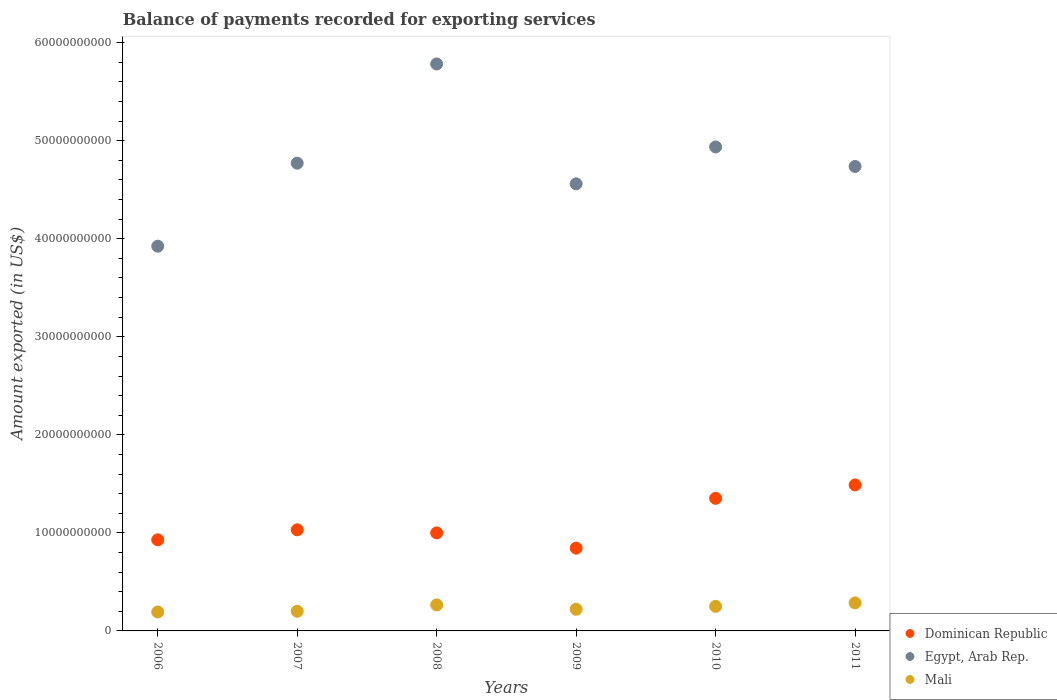What is the amount exported in Egypt, Arab Rep. in 2007?
Your answer should be very brief. 4.77e+1. Across all years, what is the maximum amount exported in Dominican Republic?
Make the answer very short. 1.49e+1. Across all years, what is the minimum amount exported in Dominican Republic?
Offer a very short reply. 8.44e+09. In which year was the amount exported in Egypt, Arab Rep. minimum?
Ensure brevity in your answer.  2006. What is the total amount exported in Mali in the graph?
Offer a terse response. 1.42e+1. What is the difference between the amount exported in Egypt, Arab Rep. in 2007 and that in 2011?
Give a very brief answer. 3.36e+08. What is the difference between the amount exported in Egypt, Arab Rep. in 2008 and the amount exported in Dominican Republic in 2007?
Your answer should be compact. 4.75e+1. What is the average amount exported in Dominican Republic per year?
Your answer should be very brief. 1.11e+1. In the year 2006, what is the difference between the amount exported in Dominican Republic and amount exported in Mali?
Provide a short and direct response. 7.36e+09. What is the ratio of the amount exported in Egypt, Arab Rep. in 2009 to that in 2011?
Provide a short and direct response. 0.96. Is the amount exported in Mali in 2006 less than that in 2011?
Your response must be concise. Yes. What is the difference between the highest and the second highest amount exported in Mali?
Offer a terse response. 2.06e+08. What is the difference between the highest and the lowest amount exported in Dominican Republic?
Ensure brevity in your answer.  6.45e+09. Is the sum of the amount exported in Mali in 2006 and 2009 greater than the maximum amount exported in Dominican Republic across all years?
Your response must be concise. No. Does the graph contain any zero values?
Keep it short and to the point. No. Does the graph contain grids?
Provide a succinct answer. No. Where does the legend appear in the graph?
Ensure brevity in your answer.  Bottom right. How many legend labels are there?
Your response must be concise. 3. What is the title of the graph?
Provide a succinct answer. Balance of payments recorded for exporting services. What is the label or title of the Y-axis?
Provide a succinct answer. Amount exported (in US$). What is the Amount exported (in US$) of Dominican Republic in 2006?
Make the answer very short. 9.29e+09. What is the Amount exported (in US$) in Egypt, Arab Rep. in 2006?
Provide a short and direct response. 3.92e+1. What is the Amount exported (in US$) in Mali in 2006?
Your answer should be compact. 1.93e+09. What is the Amount exported (in US$) in Dominican Republic in 2007?
Ensure brevity in your answer.  1.03e+1. What is the Amount exported (in US$) of Egypt, Arab Rep. in 2007?
Your response must be concise. 4.77e+1. What is the Amount exported (in US$) of Mali in 2007?
Provide a succinct answer. 2.00e+09. What is the Amount exported (in US$) of Dominican Republic in 2008?
Offer a terse response. 1.00e+1. What is the Amount exported (in US$) in Egypt, Arab Rep. in 2008?
Ensure brevity in your answer.  5.78e+1. What is the Amount exported (in US$) of Mali in 2008?
Your answer should be compact. 2.65e+09. What is the Amount exported (in US$) in Dominican Republic in 2009?
Provide a short and direct response. 8.44e+09. What is the Amount exported (in US$) of Egypt, Arab Rep. in 2009?
Offer a very short reply. 4.56e+1. What is the Amount exported (in US$) of Mali in 2009?
Give a very brief answer. 2.21e+09. What is the Amount exported (in US$) in Dominican Republic in 2010?
Offer a terse response. 1.35e+1. What is the Amount exported (in US$) in Egypt, Arab Rep. in 2010?
Make the answer very short. 4.94e+1. What is the Amount exported (in US$) in Mali in 2010?
Keep it short and to the point. 2.51e+09. What is the Amount exported (in US$) of Dominican Republic in 2011?
Provide a succinct answer. 1.49e+1. What is the Amount exported (in US$) in Egypt, Arab Rep. in 2011?
Offer a terse response. 4.74e+1. What is the Amount exported (in US$) of Mali in 2011?
Your answer should be compact. 2.86e+09. Across all years, what is the maximum Amount exported (in US$) in Dominican Republic?
Give a very brief answer. 1.49e+1. Across all years, what is the maximum Amount exported (in US$) in Egypt, Arab Rep.?
Offer a terse response. 5.78e+1. Across all years, what is the maximum Amount exported (in US$) in Mali?
Your response must be concise. 2.86e+09. Across all years, what is the minimum Amount exported (in US$) in Dominican Republic?
Keep it short and to the point. 8.44e+09. Across all years, what is the minimum Amount exported (in US$) in Egypt, Arab Rep.?
Offer a very short reply. 3.92e+1. Across all years, what is the minimum Amount exported (in US$) of Mali?
Provide a succinct answer. 1.93e+09. What is the total Amount exported (in US$) of Dominican Republic in the graph?
Provide a short and direct response. 6.65e+1. What is the total Amount exported (in US$) of Egypt, Arab Rep. in the graph?
Your answer should be compact. 2.87e+11. What is the total Amount exported (in US$) in Mali in the graph?
Provide a short and direct response. 1.42e+1. What is the difference between the Amount exported (in US$) in Dominican Republic in 2006 and that in 2007?
Provide a short and direct response. -1.02e+09. What is the difference between the Amount exported (in US$) of Egypt, Arab Rep. in 2006 and that in 2007?
Your answer should be compact. -8.47e+09. What is the difference between the Amount exported (in US$) in Mali in 2006 and that in 2007?
Give a very brief answer. -7.17e+07. What is the difference between the Amount exported (in US$) in Dominican Republic in 2006 and that in 2008?
Provide a short and direct response. -7.08e+08. What is the difference between the Amount exported (in US$) of Egypt, Arab Rep. in 2006 and that in 2008?
Make the answer very short. -1.86e+1. What is the difference between the Amount exported (in US$) in Mali in 2006 and that in 2008?
Your answer should be compact. -7.21e+08. What is the difference between the Amount exported (in US$) of Dominican Republic in 2006 and that in 2009?
Your response must be concise. 8.48e+08. What is the difference between the Amount exported (in US$) of Egypt, Arab Rep. in 2006 and that in 2009?
Your response must be concise. -6.36e+09. What is the difference between the Amount exported (in US$) in Mali in 2006 and that in 2009?
Provide a short and direct response. -2.77e+08. What is the difference between the Amount exported (in US$) of Dominican Republic in 2006 and that in 2010?
Offer a very short reply. -4.23e+09. What is the difference between the Amount exported (in US$) of Egypt, Arab Rep. in 2006 and that in 2010?
Provide a short and direct response. -1.01e+1. What is the difference between the Amount exported (in US$) of Mali in 2006 and that in 2010?
Provide a short and direct response. -5.76e+08. What is the difference between the Amount exported (in US$) in Dominican Republic in 2006 and that in 2011?
Your answer should be very brief. -5.60e+09. What is the difference between the Amount exported (in US$) in Egypt, Arab Rep. in 2006 and that in 2011?
Your answer should be very brief. -8.13e+09. What is the difference between the Amount exported (in US$) in Mali in 2006 and that in 2011?
Your answer should be compact. -9.26e+08. What is the difference between the Amount exported (in US$) in Dominican Republic in 2007 and that in 2008?
Give a very brief answer. 3.16e+08. What is the difference between the Amount exported (in US$) of Egypt, Arab Rep. in 2007 and that in 2008?
Your answer should be compact. -1.01e+1. What is the difference between the Amount exported (in US$) in Mali in 2007 and that in 2008?
Ensure brevity in your answer.  -6.49e+08. What is the difference between the Amount exported (in US$) of Dominican Republic in 2007 and that in 2009?
Provide a succinct answer. 1.87e+09. What is the difference between the Amount exported (in US$) of Egypt, Arab Rep. in 2007 and that in 2009?
Give a very brief answer. 2.11e+09. What is the difference between the Amount exported (in US$) of Mali in 2007 and that in 2009?
Provide a short and direct response. -2.05e+08. What is the difference between the Amount exported (in US$) in Dominican Republic in 2007 and that in 2010?
Offer a very short reply. -3.21e+09. What is the difference between the Amount exported (in US$) in Egypt, Arab Rep. in 2007 and that in 2010?
Offer a very short reply. -1.66e+09. What is the difference between the Amount exported (in US$) in Mali in 2007 and that in 2010?
Ensure brevity in your answer.  -5.04e+08. What is the difference between the Amount exported (in US$) of Dominican Republic in 2007 and that in 2011?
Ensure brevity in your answer.  -4.58e+09. What is the difference between the Amount exported (in US$) in Egypt, Arab Rep. in 2007 and that in 2011?
Ensure brevity in your answer.  3.36e+08. What is the difference between the Amount exported (in US$) of Mali in 2007 and that in 2011?
Keep it short and to the point. -8.55e+08. What is the difference between the Amount exported (in US$) in Dominican Republic in 2008 and that in 2009?
Ensure brevity in your answer.  1.56e+09. What is the difference between the Amount exported (in US$) in Egypt, Arab Rep. in 2008 and that in 2009?
Provide a succinct answer. 1.22e+1. What is the difference between the Amount exported (in US$) in Mali in 2008 and that in 2009?
Offer a terse response. 4.43e+08. What is the difference between the Amount exported (in US$) of Dominican Republic in 2008 and that in 2010?
Your response must be concise. -3.53e+09. What is the difference between the Amount exported (in US$) in Egypt, Arab Rep. in 2008 and that in 2010?
Make the answer very short. 8.46e+09. What is the difference between the Amount exported (in US$) of Mali in 2008 and that in 2010?
Ensure brevity in your answer.  1.45e+08. What is the difference between the Amount exported (in US$) of Dominican Republic in 2008 and that in 2011?
Give a very brief answer. -4.89e+09. What is the difference between the Amount exported (in US$) in Egypt, Arab Rep. in 2008 and that in 2011?
Offer a very short reply. 1.05e+1. What is the difference between the Amount exported (in US$) in Mali in 2008 and that in 2011?
Give a very brief answer. -2.06e+08. What is the difference between the Amount exported (in US$) of Dominican Republic in 2009 and that in 2010?
Ensure brevity in your answer.  -5.08e+09. What is the difference between the Amount exported (in US$) in Egypt, Arab Rep. in 2009 and that in 2010?
Give a very brief answer. -3.76e+09. What is the difference between the Amount exported (in US$) of Mali in 2009 and that in 2010?
Give a very brief answer. -2.98e+08. What is the difference between the Amount exported (in US$) in Dominican Republic in 2009 and that in 2011?
Your response must be concise. -6.45e+09. What is the difference between the Amount exported (in US$) of Egypt, Arab Rep. in 2009 and that in 2011?
Offer a very short reply. -1.77e+09. What is the difference between the Amount exported (in US$) of Mali in 2009 and that in 2011?
Provide a short and direct response. -6.49e+08. What is the difference between the Amount exported (in US$) of Dominican Republic in 2010 and that in 2011?
Keep it short and to the point. -1.36e+09. What is the difference between the Amount exported (in US$) in Egypt, Arab Rep. in 2010 and that in 2011?
Provide a succinct answer. 1.99e+09. What is the difference between the Amount exported (in US$) of Mali in 2010 and that in 2011?
Offer a terse response. -3.51e+08. What is the difference between the Amount exported (in US$) of Dominican Republic in 2006 and the Amount exported (in US$) of Egypt, Arab Rep. in 2007?
Your answer should be compact. -3.84e+1. What is the difference between the Amount exported (in US$) in Dominican Republic in 2006 and the Amount exported (in US$) in Mali in 2007?
Keep it short and to the point. 7.29e+09. What is the difference between the Amount exported (in US$) of Egypt, Arab Rep. in 2006 and the Amount exported (in US$) of Mali in 2007?
Ensure brevity in your answer.  3.72e+1. What is the difference between the Amount exported (in US$) in Dominican Republic in 2006 and the Amount exported (in US$) in Egypt, Arab Rep. in 2008?
Give a very brief answer. -4.85e+1. What is the difference between the Amount exported (in US$) of Dominican Republic in 2006 and the Amount exported (in US$) of Mali in 2008?
Give a very brief answer. 6.64e+09. What is the difference between the Amount exported (in US$) of Egypt, Arab Rep. in 2006 and the Amount exported (in US$) of Mali in 2008?
Make the answer very short. 3.66e+1. What is the difference between the Amount exported (in US$) in Dominican Republic in 2006 and the Amount exported (in US$) in Egypt, Arab Rep. in 2009?
Ensure brevity in your answer.  -3.63e+1. What is the difference between the Amount exported (in US$) in Dominican Republic in 2006 and the Amount exported (in US$) in Mali in 2009?
Offer a very short reply. 7.08e+09. What is the difference between the Amount exported (in US$) of Egypt, Arab Rep. in 2006 and the Amount exported (in US$) of Mali in 2009?
Ensure brevity in your answer.  3.70e+1. What is the difference between the Amount exported (in US$) in Dominican Republic in 2006 and the Amount exported (in US$) in Egypt, Arab Rep. in 2010?
Your answer should be compact. -4.01e+1. What is the difference between the Amount exported (in US$) in Dominican Republic in 2006 and the Amount exported (in US$) in Mali in 2010?
Offer a very short reply. 6.78e+09. What is the difference between the Amount exported (in US$) in Egypt, Arab Rep. in 2006 and the Amount exported (in US$) in Mali in 2010?
Your response must be concise. 3.67e+1. What is the difference between the Amount exported (in US$) of Dominican Republic in 2006 and the Amount exported (in US$) of Egypt, Arab Rep. in 2011?
Offer a terse response. -3.81e+1. What is the difference between the Amount exported (in US$) in Dominican Republic in 2006 and the Amount exported (in US$) in Mali in 2011?
Make the answer very short. 6.43e+09. What is the difference between the Amount exported (in US$) of Egypt, Arab Rep. in 2006 and the Amount exported (in US$) of Mali in 2011?
Offer a very short reply. 3.64e+1. What is the difference between the Amount exported (in US$) of Dominican Republic in 2007 and the Amount exported (in US$) of Egypt, Arab Rep. in 2008?
Ensure brevity in your answer.  -4.75e+1. What is the difference between the Amount exported (in US$) of Dominican Republic in 2007 and the Amount exported (in US$) of Mali in 2008?
Your response must be concise. 7.66e+09. What is the difference between the Amount exported (in US$) of Egypt, Arab Rep. in 2007 and the Amount exported (in US$) of Mali in 2008?
Ensure brevity in your answer.  4.51e+1. What is the difference between the Amount exported (in US$) in Dominican Republic in 2007 and the Amount exported (in US$) in Egypt, Arab Rep. in 2009?
Provide a short and direct response. -3.53e+1. What is the difference between the Amount exported (in US$) of Dominican Republic in 2007 and the Amount exported (in US$) of Mali in 2009?
Provide a succinct answer. 8.10e+09. What is the difference between the Amount exported (in US$) of Egypt, Arab Rep. in 2007 and the Amount exported (in US$) of Mali in 2009?
Provide a succinct answer. 4.55e+1. What is the difference between the Amount exported (in US$) of Dominican Republic in 2007 and the Amount exported (in US$) of Egypt, Arab Rep. in 2010?
Provide a succinct answer. -3.91e+1. What is the difference between the Amount exported (in US$) of Dominican Republic in 2007 and the Amount exported (in US$) of Mali in 2010?
Make the answer very short. 7.81e+09. What is the difference between the Amount exported (in US$) of Egypt, Arab Rep. in 2007 and the Amount exported (in US$) of Mali in 2010?
Your answer should be compact. 4.52e+1. What is the difference between the Amount exported (in US$) in Dominican Republic in 2007 and the Amount exported (in US$) in Egypt, Arab Rep. in 2011?
Provide a succinct answer. -3.71e+1. What is the difference between the Amount exported (in US$) in Dominican Republic in 2007 and the Amount exported (in US$) in Mali in 2011?
Make the answer very short. 7.45e+09. What is the difference between the Amount exported (in US$) in Egypt, Arab Rep. in 2007 and the Amount exported (in US$) in Mali in 2011?
Make the answer very short. 4.48e+1. What is the difference between the Amount exported (in US$) of Dominican Republic in 2008 and the Amount exported (in US$) of Egypt, Arab Rep. in 2009?
Offer a very short reply. -3.56e+1. What is the difference between the Amount exported (in US$) in Dominican Republic in 2008 and the Amount exported (in US$) in Mali in 2009?
Provide a succinct answer. 7.79e+09. What is the difference between the Amount exported (in US$) in Egypt, Arab Rep. in 2008 and the Amount exported (in US$) in Mali in 2009?
Make the answer very short. 5.56e+1. What is the difference between the Amount exported (in US$) of Dominican Republic in 2008 and the Amount exported (in US$) of Egypt, Arab Rep. in 2010?
Your response must be concise. -3.94e+1. What is the difference between the Amount exported (in US$) of Dominican Republic in 2008 and the Amount exported (in US$) of Mali in 2010?
Your answer should be compact. 7.49e+09. What is the difference between the Amount exported (in US$) of Egypt, Arab Rep. in 2008 and the Amount exported (in US$) of Mali in 2010?
Offer a terse response. 5.53e+1. What is the difference between the Amount exported (in US$) of Dominican Republic in 2008 and the Amount exported (in US$) of Egypt, Arab Rep. in 2011?
Your answer should be compact. -3.74e+1. What is the difference between the Amount exported (in US$) of Dominican Republic in 2008 and the Amount exported (in US$) of Mali in 2011?
Your response must be concise. 7.14e+09. What is the difference between the Amount exported (in US$) of Egypt, Arab Rep. in 2008 and the Amount exported (in US$) of Mali in 2011?
Ensure brevity in your answer.  5.50e+1. What is the difference between the Amount exported (in US$) of Dominican Republic in 2009 and the Amount exported (in US$) of Egypt, Arab Rep. in 2010?
Provide a short and direct response. -4.09e+1. What is the difference between the Amount exported (in US$) in Dominican Republic in 2009 and the Amount exported (in US$) in Mali in 2010?
Ensure brevity in your answer.  5.94e+09. What is the difference between the Amount exported (in US$) in Egypt, Arab Rep. in 2009 and the Amount exported (in US$) in Mali in 2010?
Provide a short and direct response. 4.31e+1. What is the difference between the Amount exported (in US$) of Dominican Republic in 2009 and the Amount exported (in US$) of Egypt, Arab Rep. in 2011?
Offer a very short reply. -3.89e+1. What is the difference between the Amount exported (in US$) in Dominican Republic in 2009 and the Amount exported (in US$) in Mali in 2011?
Offer a terse response. 5.58e+09. What is the difference between the Amount exported (in US$) of Egypt, Arab Rep. in 2009 and the Amount exported (in US$) of Mali in 2011?
Provide a succinct answer. 4.27e+1. What is the difference between the Amount exported (in US$) of Dominican Republic in 2010 and the Amount exported (in US$) of Egypt, Arab Rep. in 2011?
Offer a terse response. -3.38e+1. What is the difference between the Amount exported (in US$) in Dominican Republic in 2010 and the Amount exported (in US$) in Mali in 2011?
Give a very brief answer. 1.07e+1. What is the difference between the Amount exported (in US$) in Egypt, Arab Rep. in 2010 and the Amount exported (in US$) in Mali in 2011?
Provide a short and direct response. 4.65e+1. What is the average Amount exported (in US$) of Dominican Republic per year?
Ensure brevity in your answer.  1.11e+1. What is the average Amount exported (in US$) of Egypt, Arab Rep. per year?
Offer a very short reply. 4.79e+1. What is the average Amount exported (in US$) in Mali per year?
Your response must be concise. 2.36e+09. In the year 2006, what is the difference between the Amount exported (in US$) in Dominican Republic and Amount exported (in US$) in Egypt, Arab Rep.?
Your answer should be compact. -2.99e+1. In the year 2006, what is the difference between the Amount exported (in US$) of Dominican Republic and Amount exported (in US$) of Mali?
Give a very brief answer. 7.36e+09. In the year 2006, what is the difference between the Amount exported (in US$) in Egypt, Arab Rep. and Amount exported (in US$) in Mali?
Provide a short and direct response. 3.73e+1. In the year 2007, what is the difference between the Amount exported (in US$) of Dominican Republic and Amount exported (in US$) of Egypt, Arab Rep.?
Ensure brevity in your answer.  -3.74e+1. In the year 2007, what is the difference between the Amount exported (in US$) in Dominican Republic and Amount exported (in US$) in Mali?
Provide a succinct answer. 8.31e+09. In the year 2007, what is the difference between the Amount exported (in US$) of Egypt, Arab Rep. and Amount exported (in US$) of Mali?
Keep it short and to the point. 4.57e+1. In the year 2008, what is the difference between the Amount exported (in US$) of Dominican Republic and Amount exported (in US$) of Egypt, Arab Rep.?
Give a very brief answer. -4.78e+1. In the year 2008, what is the difference between the Amount exported (in US$) in Dominican Republic and Amount exported (in US$) in Mali?
Your answer should be very brief. 7.35e+09. In the year 2008, what is the difference between the Amount exported (in US$) of Egypt, Arab Rep. and Amount exported (in US$) of Mali?
Provide a succinct answer. 5.52e+1. In the year 2009, what is the difference between the Amount exported (in US$) in Dominican Republic and Amount exported (in US$) in Egypt, Arab Rep.?
Make the answer very short. -3.72e+1. In the year 2009, what is the difference between the Amount exported (in US$) of Dominican Republic and Amount exported (in US$) of Mali?
Provide a short and direct response. 6.23e+09. In the year 2009, what is the difference between the Amount exported (in US$) in Egypt, Arab Rep. and Amount exported (in US$) in Mali?
Keep it short and to the point. 4.34e+1. In the year 2010, what is the difference between the Amount exported (in US$) of Dominican Republic and Amount exported (in US$) of Egypt, Arab Rep.?
Make the answer very short. -3.58e+1. In the year 2010, what is the difference between the Amount exported (in US$) of Dominican Republic and Amount exported (in US$) of Mali?
Offer a terse response. 1.10e+1. In the year 2010, what is the difference between the Amount exported (in US$) in Egypt, Arab Rep. and Amount exported (in US$) in Mali?
Make the answer very short. 4.69e+1. In the year 2011, what is the difference between the Amount exported (in US$) in Dominican Republic and Amount exported (in US$) in Egypt, Arab Rep.?
Provide a succinct answer. -3.25e+1. In the year 2011, what is the difference between the Amount exported (in US$) of Dominican Republic and Amount exported (in US$) of Mali?
Your answer should be very brief. 1.20e+1. In the year 2011, what is the difference between the Amount exported (in US$) in Egypt, Arab Rep. and Amount exported (in US$) in Mali?
Provide a succinct answer. 4.45e+1. What is the ratio of the Amount exported (in US$) in Dominican Republic in 2006 to that in 2007?
Your answer should be compact. 0.9. What is the ratio of the Amount exported (in US$) in Egypt, Arab Rep. in 2006 to that in 2007?
Ensure brevity in your answer.  0.82. What is the ratio of the Amount exported (in US$) in Mali in 2006 to that in 2007?
Provide a short and direct response. 0.96. What is the ratio of the Amount exported (in US$) of Dominican Republic in 2006 to that in 2008?
Offer a very short reply. 0.93. What is the ratio of the Amount exported (in US$) of Egypt, Arab Rep. in 2006 to that in 2008?
Make the answer very short. 0.68. What is the ratio of the Amount exported (in US$) of Mali in 2006 to that in 2008?
Give a very brief answer. 0.73. What is the ratio of the Amount exported (in US$) in Dominican Republic in 2006 to that in 2009?
Provide a short and direct response. 1.1. What is the ratio of the Amount exported (in US$) in Egypt, Arab Rep. in 2006 to that in 2009?
Ensure brevity in your answer.  0.86. What is the ratio of the Amount exported (in US$) in Mali in 2006 to that in 2009?
Offer a terse response. 0.87. What is the ratio of the Amount exported (in US$) in Dominican Republic in 2006 to that in 2010?
Give a very brief answer. 0.69. What is the ratio of the Amount exported (in US$) of Egypt, Arab Rep. in 2006 to that in 2010?
Ensure brevity in your answer.  0.79. What is the ratio of the Amount exported (in US$) of Mali in 2006 to that in 2010?
Make the answer very short. 0.77. What is the ratio of the Amount exported (in US$) of Dominican Republic in 2006 to that in 2011?
Provide a succinct answer. 0.62. What is the ratio of the Amount exported (in US$) in Egypt, Arab Rep. in 2006 to that in 2011?
Keep it short and to the point. 0.83. What is the ratio of the Amount exported (in US$) in Mali in 2006 to that in 2011?
Your answer should be compact. 0.68. What is the ratio of the Amount exported (in US$) in Dominican Republic in 2007 to that in 2008?
Make the answer very short. 1.03. What is the ratio of the Amount exported (in US$) in Egypt, Arab Rep. in 2007 to that in 2008?
Provide a short and direct response. 0.82. What is the ratio of the Amount exported (in US$) of Mali in 2007 to that in 2008?
Your response must be concise. 0.76. What is the ratio of the Amount exported (in US$) in Dominican Republic in 2007 to that in 2009?
Provide a short and direct response. 1.22. What is the ratio of the Amount exported (in US$) of Egypt, Arab Rep. in 2007 to that in 2009?
Ensure brevity in your answer.  1.05. What is the ratio of the Amount exported (in US$) in Mali in 2007 to that in 2009?
Ensure brevity in your answer.  0.91. What is the ratio of the Amount exported (in US$) of Dominican Republic in 2007 to that in 2010?
Offer a very short reply. 0.76. What is the ratio of the Amount exported (in US$) of Egypt, Arab Rep. in 2007 to that in 2010?
Provide a short and direct response. 0.97. What is the ratio of the Amount exported (in US$) of Mali in 2007 to that in 2010?
Ensure brevity in your answer.  0.8. What is the ratio of the Amount exported (in US$) in Dominican Republic in 2007 to that in 2011?
Ensure brevity in your answer.  0.69. What is the ratio of the Amount exported (in US$) in Egypt, Arab Rep. in 2007 to that in 2011?
Offer a terse response. 1.01. What is the ratio of the Amount exported (in US$) of Mali in 2007 to that in 2011?
Ensure brevity in your answer.  0.7. What is the ratio of the Amount exported (in US$) in Dominican Republic in 2008 to that in 2009?
Give a very brief answer. 1.18. What is the ratio of the Amount exported (in US$) in Egypt, Arab Rep. in 2008 to that in 2009?
Your answer should be very brief. 1.27. What is the ratio of the Amount exported (in US$) in Mali in 2008 to that in 2009?
Give a very brief answer. 1.2. What is the ratio of the Amount exported (in US$) of Dominican Republic in 2008 to that in 2010?
Make the answer very short. 0.74. What is the ratio of the Amount exported (in US$) of Egypt, Arab Rep. in 2008 to that in 2010?
Keep it short and to the point. 1.17. What is the ratio of the Amount exported (in US$) of Mali in 2008 to that in 2010?
Your response must be concise. 1.06. What is the ratio of the Amount exported (in US$) of Dominican Republic in 2008 to that in 2011?
Keep it short and to the point. 0.67. What is the ratio of the Amount exported (in US$) of Egypt, Arab Rep. in 2008 to that in 2011?
Provide a short and direct response. 1.22. What is the ratio of the Amount exported (in US$) in Mali in 2008 to that in 2011?
Your answer should be very brief. 0.93. What is the ratio of the Amount exported (in US$) of Dominican Republic in 2009 to that in 2010?
Offer a terse response. 0.62. What is the ratio of the Amount exported (in US$) in Egypt, Arab Rep. in 2009 to that in 2010?
Your response must be concise. 0.92. What is the ratio of the Amount exported (in US$) of Mali in 2009 to that in 2010?
Keep it short and to the point. 0.88. What is the ratio of the Amount exported (in US$) of Dominican Republic in 2009 to that in 2011?
Offer a terse response. 0.57. What is the ratio of the Amount exported (in US$) of Egypt, Arab Rep. in 2009 to that in 2011?
Offer a terse response. 0.96. What is the ratio of the Amount exported (in US$) of Mali in 2009 to that in 2011?
Your answer should be very brief. 0.77. What is the ratio of the Amount exported (in US$) in Dominican Republic in 2010 to that in 2011?
Offer a very short reply. 0.91. What is the ratio of the Amount exported (in US$) of Egypt, Arab Rep. in 2010 to that in 2011?
Your response must be concise. 1.04. What is the ratio of the Amount exported (in US$) in Mali in 2010 to that in 2011?
Your answer should be compact. 0.88. What is the difference between the highest and the second highest Amount exported (in US$) in Dominican Republic?
Your answer should be very brief. 1.36e+09. What is the difference between the highest and the second highest Amount exported (in US$) of Egypt, Arab Rep.?
Ensure brevity in your answer.  8.46e+09. What is the difference between the highest and the second highest Amount exported (in US$) in Mali?
Your answer should be very brief. 2.06e+08. What is the difference between the highest and the lowest Amount exported (in US$) in Dominican Republic?
Provide a short and direct response. 6.45e+09. What is the difference between the highest and the lowest Amount exported (in US$) in Egypt, Arab Rep.?
Your answer should be very brief. 1.86e+1. What is the difference between the highest and the lowest Amount exported (in US$) in Mali?
Give a very brief answer. 9.26e+08. 